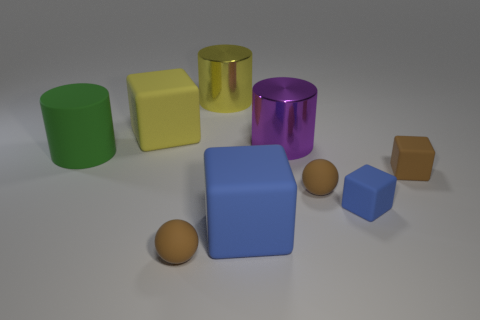Do the matte object behind the large green object and the green thing left of the large yellow metal thing have the same size?
Offer a terse response. Yes. How many objects are balls or large cubes?
Offer a very short reply. 4. There is a matte ball to the left of the big blue thing; what size is it?
Your response must be concise. Small. What number of rubber cylinders are on the right side of the yellow shiny cylinder to the right of the cube that is behind the purple cylinder?
Give a very brief answer. 0. What number of things are to the left of the big yellow metal object and on the right side of the green thing?
Make the answer very short. 2. What is the shape of the shiny object behind the big purple metal cylinder?
Provide a short and direct response. Cylinder. Is the number of brown balls that are on the left side of the big purple metal cylinder less than the number of brown matte things that are on the right side of the large yellow metallic object?
Your answer should be very brief. Yes. Is the cylinder left of the large yellow matte cube made of the same material as the cylinder that is to the right of the big yellow shiny cylinder?
Your answer should be very brief. No. The purple metal thing is what shape?
Provide a short and direct response. Cylinder. Is the number of big purple metallic things that are on the right side of the matte cylinder greater than the number of large yellow blocks that are on the right side of the big blue matte cube?
Keep it short and to the point. Yes. 